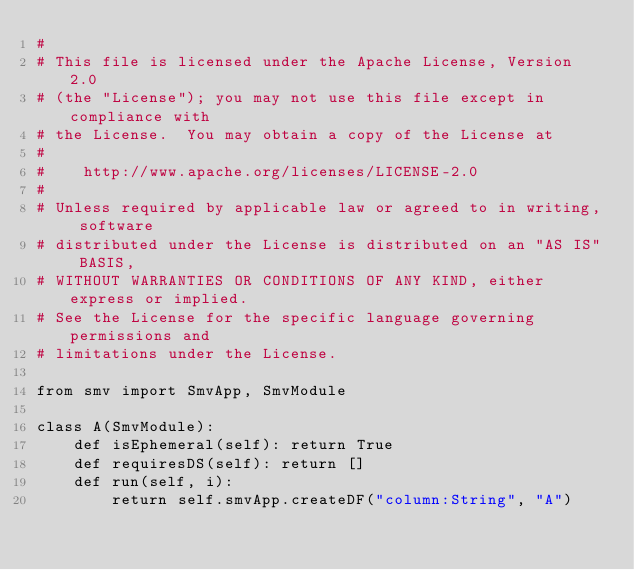Convert code to text. <code><loc_0><loc_0><loc_500><loc_500><_Python_>#
# This file is licensed under the Apache License, Version 2.0
# (the "License"); you may not use this file except in compliance with
# the License.  You may obtain a copy of the License at
#
#    http://www.apache.org/licenses/LICENSE-2.0
#
# Unless required by applicable law or agreed to in writing, software
# distributed under the License is distributed on an "AS IS" BASIS,
# WITHOUT WARRANTIES OR CONDITIONS OF ANY KIND, either express or implied.
# See the License for the specific language governing permissions and
# limitations under the License.

from smv import SmvApp, SmvModule

class A(SmvModule):
    def isEphemeral(self): return True
    def requiresDS(self): return []
    def run(self, i):
        return self.smvApp.createDF("column:String", "A")
</code> 